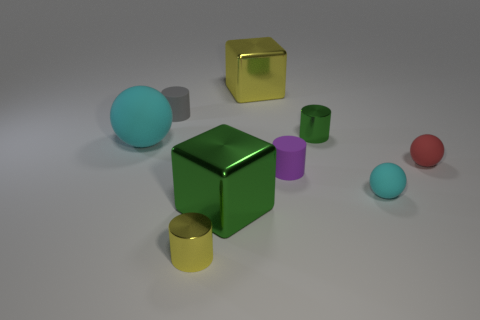The big cube that is behind the tiny green metallic object that is behind the tiny cyan object is made of what material?
Your response must be concise. Metal. Do the red matte object and the gray cylinder have the same size?
Give a very brief answer. Yes. What number of small things are either purple cylinders or cyan things?
Offer a very short reply. 2. There is a tiny gray rubber thing; how many tiny rubber balls are in front of it?
Offer a terse response. 2. Are there more small yellow cylinders behind the large matte object than small red matte things?
Offer a very short reply. No. What is the shape of the gray object that is made of the same material as the purple object?
Your response must be concise. Cylinder. The shiny cube in front of the red thing that is right of the big green cube is what color?
Your response must be concise. Green. Is the small purple object the same shape as the gray rubber object?
Provide a short and direct response. Yes. What is the material of the green object that is the same shape as the tiny gray rubber thing?
Your response must be concise. Metal. There is a cyan matte object on the right side of the rubber thing on the left side of the gray thing; are there any small cyan objects in front of it?
Make the answer very short. No. 